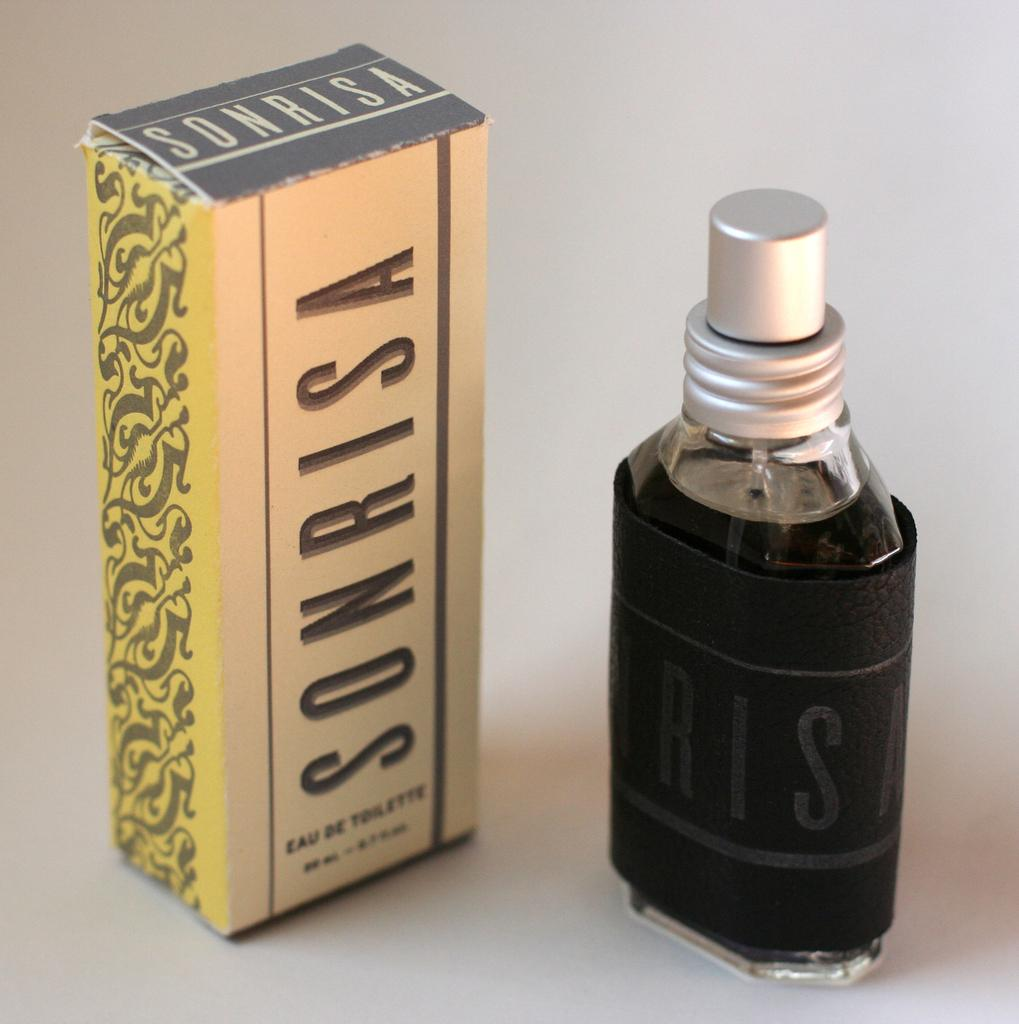Provide a one-sentence caption for the provided image. sonrisa cologne box with the bottle standing next to it. 